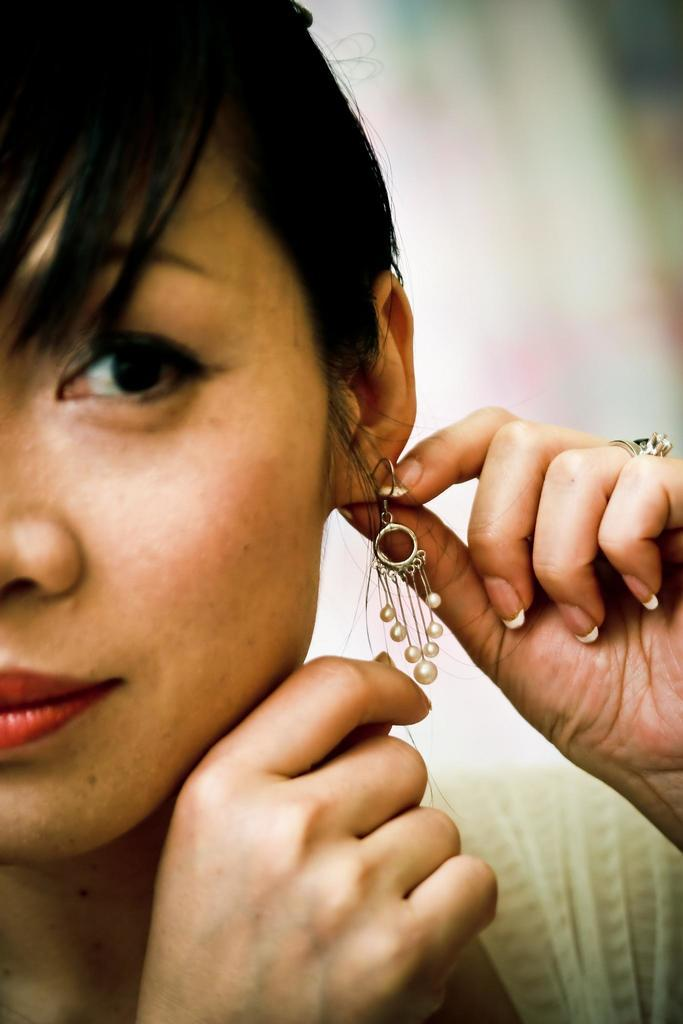Who is the main subject in the image? There is a woman in the image. What object can be seen near the woman? There is an object that resembles an earring in the image. Can you describe the background of the image? The background of the image appears blurry. What type of tooth is visible in the image? There is no tooth visible in the image. Can you describe the apparel the woman is wearing in the image? The provided facts do not mention any specific apparel the woman is wearing in the image. 